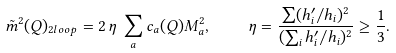<formula> <loc_0><loc_0><loc_500><loc_500>\tilde { m } ^ { 2 } ( Q ) _ { 2 l o o p } = 2 \, \eta \, \sum _ { a } c _ { a } ( Q ) M ^ { 2 } _ { a } , \quad \eta = \frac { \sum ( h ^ { \prime } _ { i } / h _ { i } ) ^ { 2 } } { ( \sum _ { i } h ^ { \prime } _ { i } / h _ { i } ) ^ { 2 } } \geq \frac { 1 } { 3 } .</formula> 